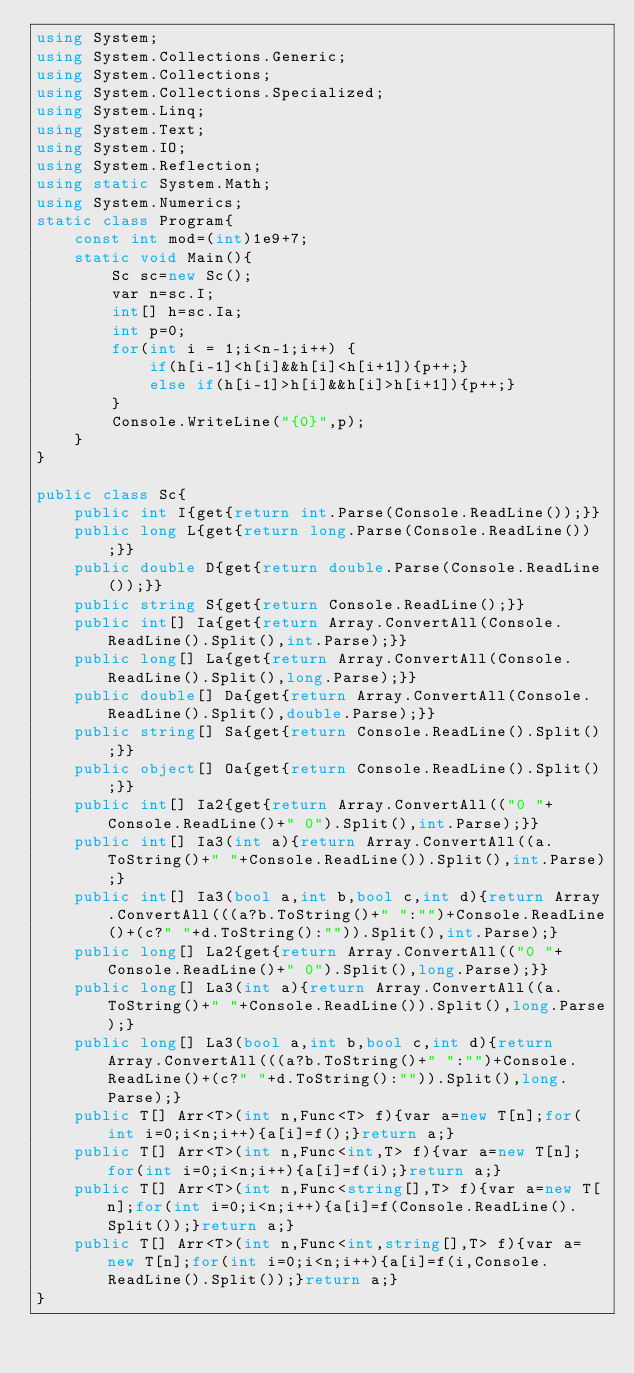Convert code to text. <code><loc_0><loc_0><loc_500><loc_500><_C#_>using System;
using System.Collections.Generic;
using System.Collections;
using System.Collections.Specialized;
using System.Linq;
using System.Text;
using System.IO;
using System.Reflection;
using static System.Math;
using System.Numerics;
static class Program{
	const int mod=(int)1e9+7;
	static void Main(){
		Sc sc=new Sc();
		var n=sc.I;
		int[] h=sc.Ia;
		int p=0;
		for(int i = 1;i<n-1;i++) {
			if(h[i-1]<h[i]&&h[i]<h[i+1]){p++;}
			else if(h[i-1]>h[i]&&h[i]>h[i+1]){p++;}
		}
		Console.WriteLine("{0}",p);
	}
}

public class Sc{
	public int I{get{return int.Parse(Console.ReadLine());}}
	public long L{get{return long.Parse(Console.ReadLine());}}
	public double D{get{return double.Parse(Console.ReadLine());}}
	public string S{get{return Console.ReadLine();}}
	public int[] Ia{get{return Array.ConvertAll(Console.ReadLine().Split(),int.Parse);}}
	public long[] La{get{return Array.ConvertAll(Console.ReadLine().Split(),long.Parse);}}
	public double[] Da{get{return Array.ConvertAll(Console.ReadLine().Split(),double.Parse);}}
	public string[] Sa{get{return Console.ReadLine().Split();}}
	public object[] Oa{get{return Console.ReadLine().Split();}}
	public int[] Ia2{get{return Array.ConvertAll(("0 "+Console.ReadLine()+" 0").Split(),int.Parse);}}
	public int[] Ia3(int a){return Array.ConvertAll((a.ToString()+" "+Console.ReadLine()).Split(),int.Parse);}
	public int[] Ia3(bool a,int b,bool c,int d){return Array.ConvertAll(((a?b.ToString()+" ":"")+Console.ReadLine()+(c?" "+d.ToString():"")).Split(),int.Parse);}
	public long[] La2{get{return Array.ConvertAll(("0 "+Console.ReadLine()+" 0").Split(),long.Parse);}}
	public long[] La3(int a){return Array.ConvertAll((a.ToString()+" "+Console.ReadLine()).Split(),long.Parse);}
	public long[] La3(bool a,int b,bool c,int d){return Array.ConvertAll(((a?b.ToString()+" ":"")+Console.ReadLine()+(c?" "+d.ToString():"")).Split(),long.Parse);}
	public T[] Arr<T>(int n,Func<T> f){var a=new T[n];for(int i=0;i<n;i++){a[i]=f();}return a;}
	public T[] Arr<T>(int n,Func<int,T> f){var a=new T[n];for(int i=0;i<n;i++){a[i]=f(i);}return a;}
	public T[] Arr<T>(int n,Func<string[],T> f){var a=new T[n];for(int i=0;i<n;i++){a[i]=f(Console.ReadLine().Split());}return a;}
	public T[] Arr<T>(int n,Func<int,string[],T> f){var a=new T[n];for(int i=0;i<n;i++){a[i]=f(i,Console.ReadLine().Split());}return a;}
}
</code> 